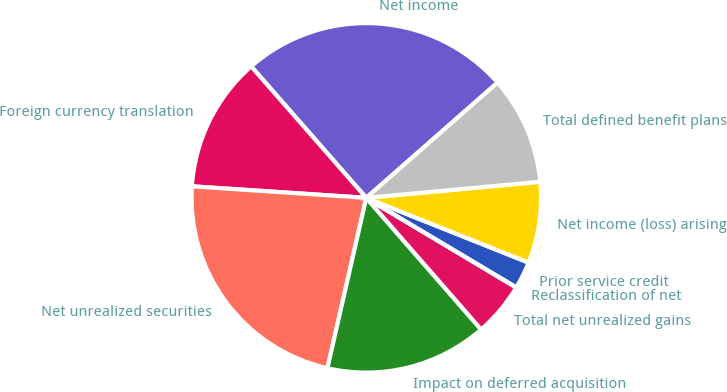<chart> <loc_0><loc_0><loc_500><loc_500><pie_chart><fcel>Net income<fcel>Foreign currency translation<fcel>Net unrealized securities<fcel>Impact on deferred acquisition<fcel>Total net unrealized gains<fcel>Reclassification of net<fcel>Prior service credit<fcel>Net income (loss) arising<fcel>Total defined benefit plans<nl><fcel>24.98%<fcel>12.5%<fcel>22.48%<fcel>14.99%<fcel>5.01%<fcel>0.02%<fcel>2.51%<fcel>7.51%<fcel>10.0%<nl></chart> 